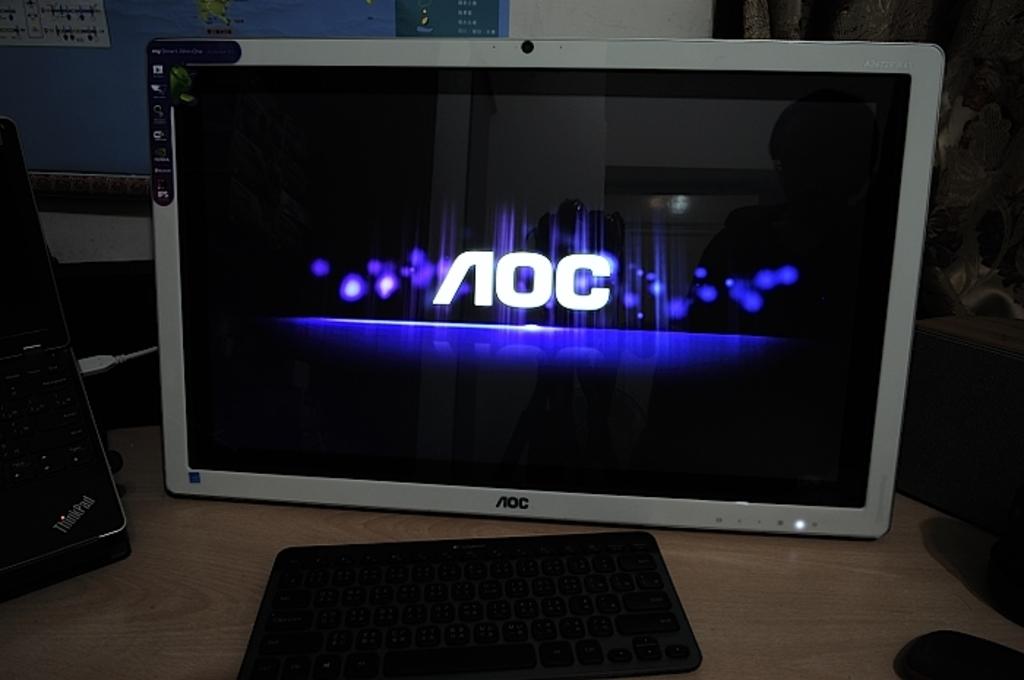What is the computer brand?
Your answer should be compact. Aoc. 